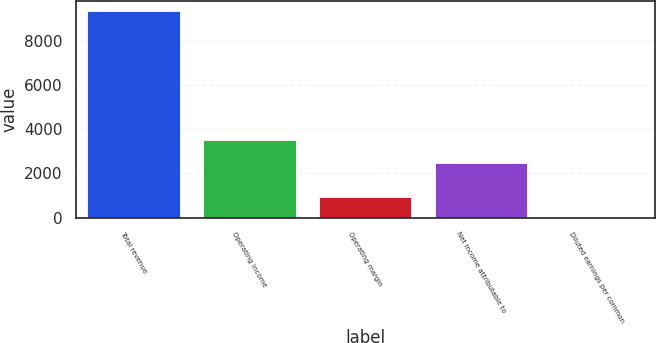Convert chart to OTSL. <chart><loc_0><loc_0><loc_500><loc_500><bar_chart><fcel>Total revenue<fcel>Operating income<fcel>Operating margin<fcel>Net income attributable to<fcel>Diluted earnings per common<nl><fcel>9337<fcel>3524<fcel>946.11<fcel>2458<fcel>13.79<nl></chart> 